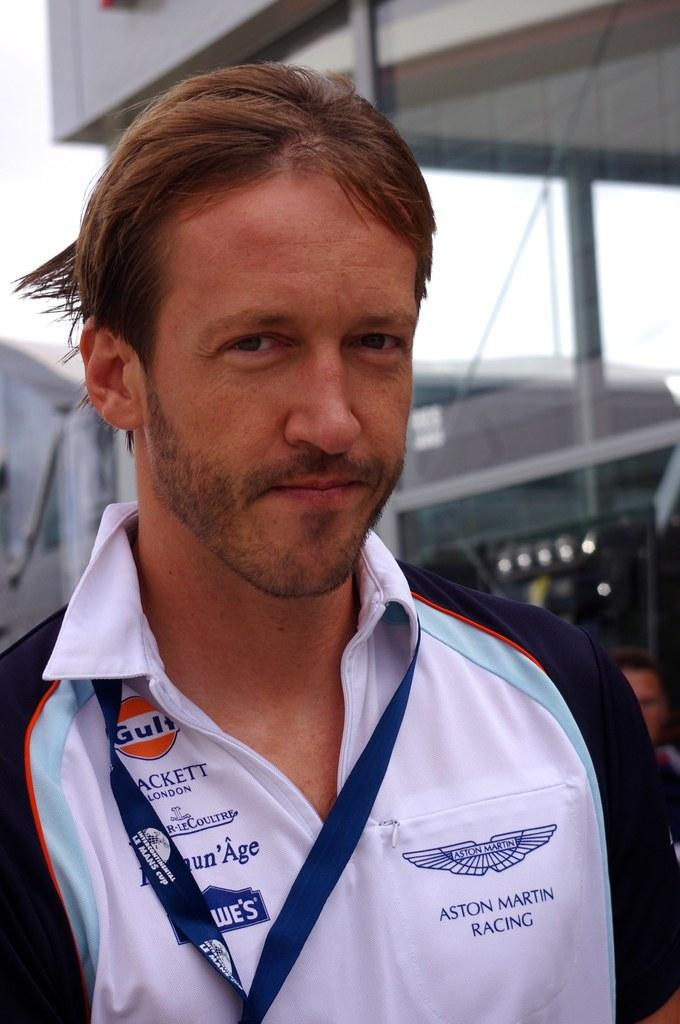<image>
Describe the image concisely. A man who is part of the Aston Martin racing team. 